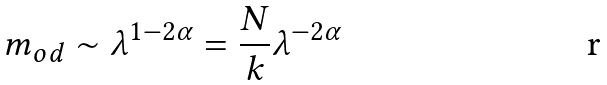<formula> <loc_0><loc_0><loc_500><loc_500>m _ { o d } \sim \lambda ^ { 1 - 2 \alpha } = \frac { N } { k } \lambda ^ { - 2 \alpha }</formula> 